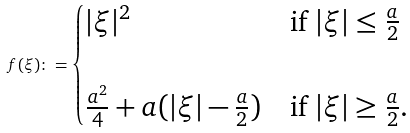Convert formula to latex. <formula><loc_0><loc_0><loc_500><loc_500>f ( \xi ) \colon = \begin{cases} | \xi | ^ { 2 } & \text {if } | \xi | \leq \frac { a } { 2 } \\ \\ \frac { a ^ { 2 } } { 4 } + a ( | \xi | - \frac { a } { 2 } ) & \text {if } | \xi | \geq \frac { a } { 2 } . \end{cases}</formula> 